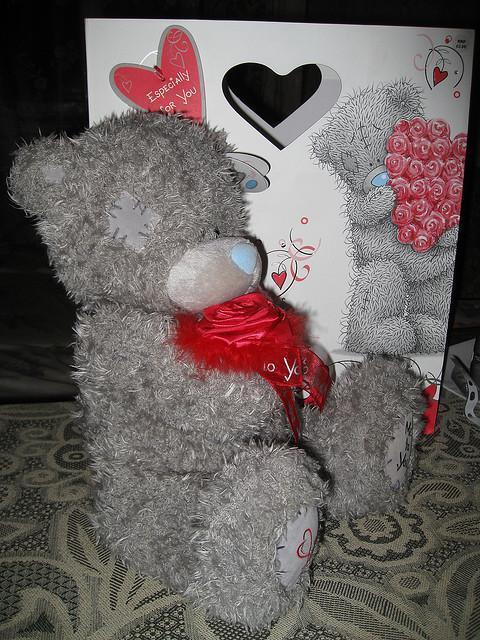How many teddy bears are there?
Give a very brief answer. 2. 